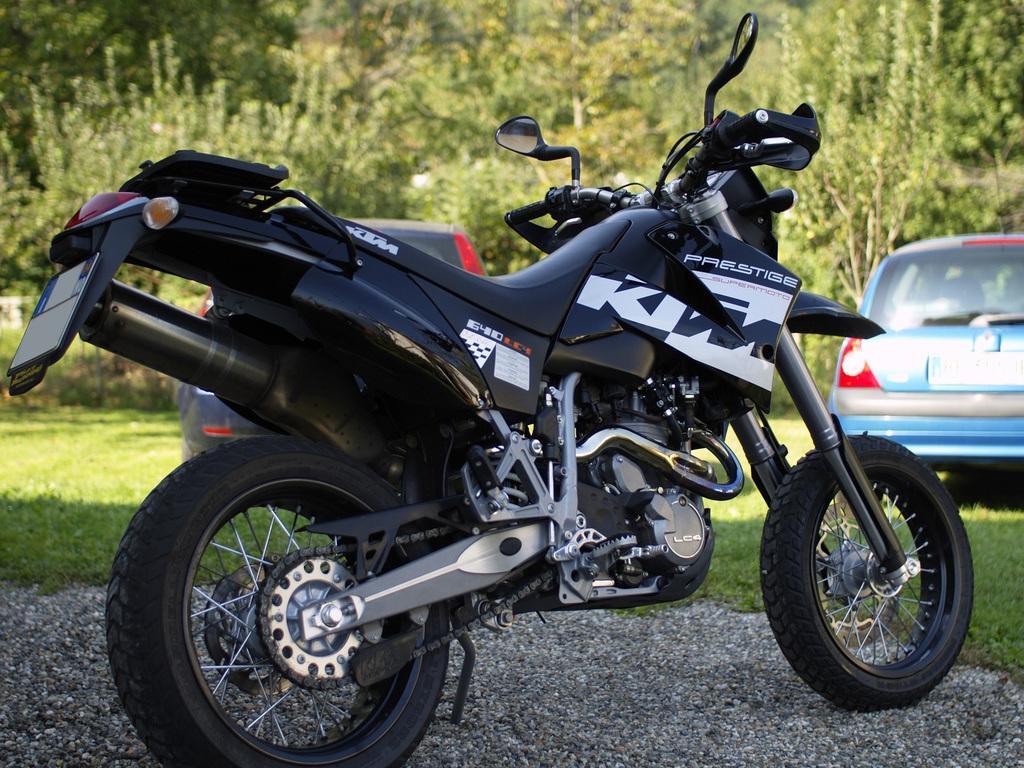Can you describe this image briefly? In this picture there is a bike which is placed near to the grass. Behind that there are two cars which are parked on the grass. In the background I can see trees and plants. 